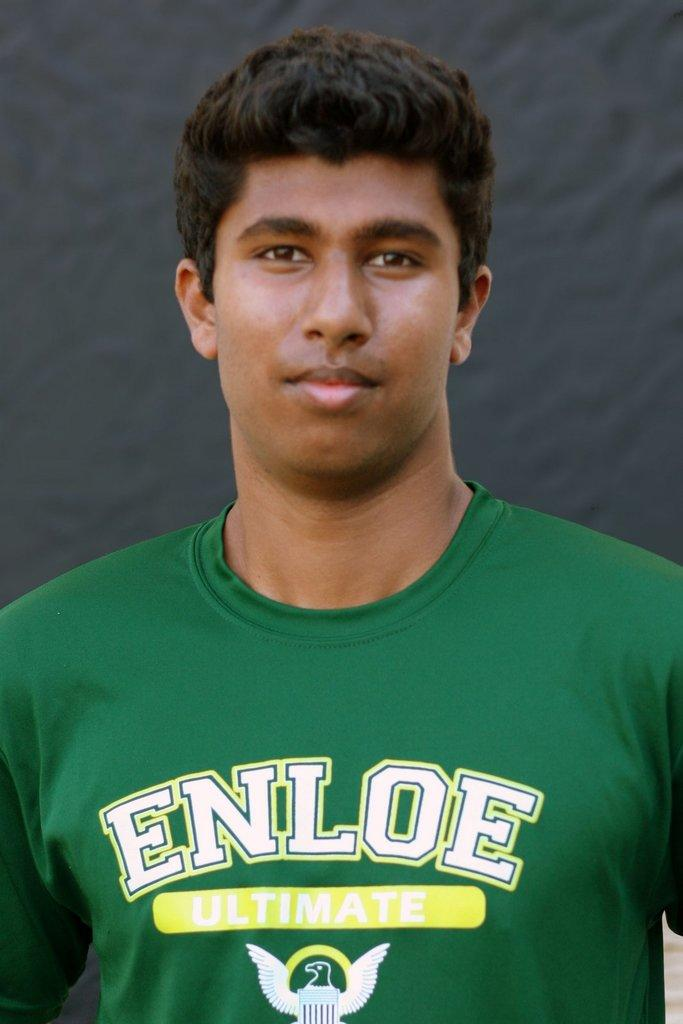Provide a one-sentence caption for the provided image. A man wearing a green shirt that reads ENLOE ULTIMATE. 